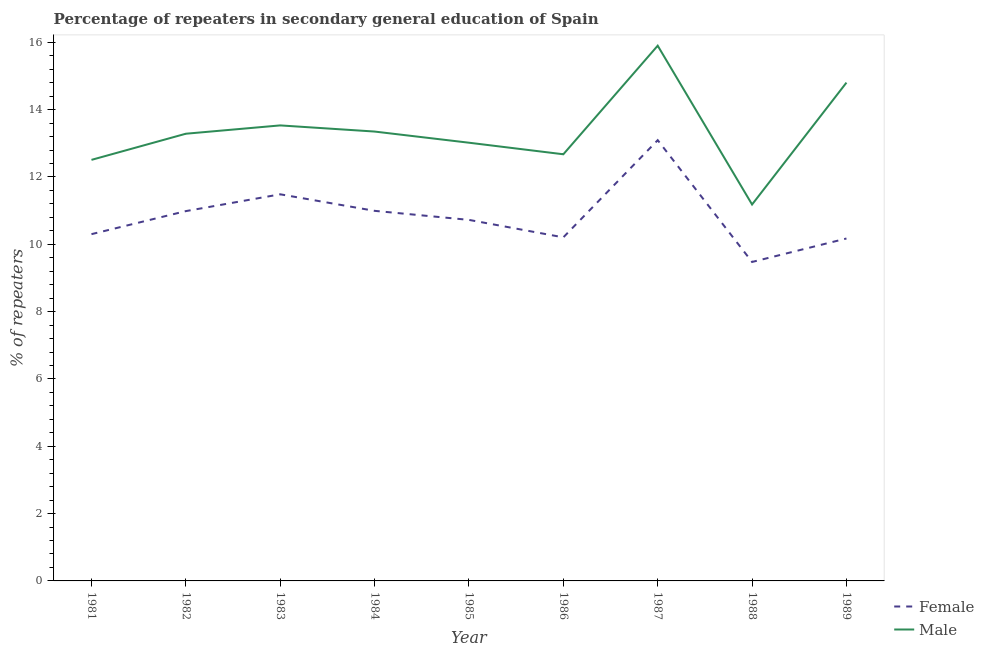Is the number of lines equal to the number of legend labels?
Offer a very short reply. Yes. What is the percentage of male repeaters in 1986?
Offer a terse response. 12.67. Across all years, what is the maximum percentage of female repeaters?
Give a very brief answer. 13.09. Across all years, what is the minimum percentage of female repeaters?
Provide a short and direct response. 9.48. In which year was the percentage of male repeaters maximum?
Your answer should be compact. 1987. In which year was the percentage of female repeaters minimum?
Your answer should be very brief. 1988. What is the total percentage of male repeaters in the graph?
Make the answer very short. 120.25. What is the difference between the percentage of female repeaters in 1982 and that in 1989?
Offer a very short reply. 0.81. What is the difference between the percentage of female repeaters in 1989 and the percentage of male repeaters in 1984?
Your response must be concise. -3.18. What is the average percentage of female repeaters per year?
Offer a terse response. 10.83. In the year 1981, what is the difference between the percentage of female repeaters and percentage of male repeaters?
Provide a succinct answer. -2.21. What is the ratio of the percentage of female repeaters in 1981 to that in 1983?
Keep it short and to the point. 0.9. Is the difference between the percentage of male repeaters in 1985 and 1987 greater than the difference between the percentage of female repeaters in 1985 and 1987?
Offer a very short reply. No. What is the difference between the highest and the second highest percentage of female repeaters?
Ensure brevity in your answer.  1.61. What is the difference between the highest and the lowest percentage of female repeaters?
Offer a terse response. 3.62. In how many years, is the percentage of female repeaters greater than the average percentage of female repeaters taken over all years?
Give a very brief answer. 4. Is the sum of the percentage of male repeaters in 1986 and 1987 greater than the maximum percentage of female repeaters across all years?
Ensure brevity in your answer.  Yes. What is the difference between two consecutive major ticks on the Y-axis?
Give a very brief answer. 2. Are the values on the major ticks of Y-axis written in scientific E-notation?
Offer a terse response. No. Does the graph contain any zero values?
Make the answer very short. No. Where does the legend appear in the graph?
Your answer should be very brief. Bottom right. How many legend labels are there?
Offer a very short reply. 2. What is the title of the graph?
Offer a very short reply. Percentage of repeaters in secondary general education of Spain. What is the label or title of the Y-axis?
Provide a short and direct response. % of repeaters. What is the % of repeaters of Female in 1981?
Your answer should be compact. 10.3. What is the % of repeaters in Male in 1981?
Ensure brevity in your answer.  12.51. What is the % of repeaters of Female in 1982?
Ensure brevity in your answer.  10.99. What is the % of repeaters of Male in 1982?
Your answer should be very brief. 13.28. What is the % of repeaters in Female in 1983?
Provide a succinct answer. 11.49. What is the % of repeaters in Male in 1983?
Your answer should be compact. 13.53. What is the % of repeaters of Female in 1984?
Ensure brevity in your answer.  10.99. What is the % of repeaters in Male in 1984?
Your response must be concise. 13.35. What is the % of repeaters in Female in 1985?
Make the answer very short. 10.73. What is the % of repeaters of Male in 1985?
Ensure brevity in your answer.  13.02. What is the % of repeaters of Female in 1986?
Your answer should be compact. 10.21. What is the % of repeaters in Male in 1986?
Provide a short and direct response. 12.67. What is the % of repeaters of Female in 1987?
Your answer should be compact. 13.09. What is the % of repeaters in Male in 1987?
Keep it short and to the point. 15.9. What is the % of repeaters in Female in 1988?
Your answer should be compact. 9.48. What is the % of repeaters of Male in 1988?
Provide a short and direct response. 11.18. What is the % of repeaters in Female in 1989?
Give a very brief answer. 10.17. What is the % of repeaters of Male in 1989?
Offer a very short reply. 14.8. Across all years, what is the maximum % of repeaters of Female?
Your answer should be compact. 13.09. Across all years, what is the maximum % of repeaters of Male?
Give a very brief answer. 15.9. Across all years, what is the minimum % of repeaters in Female?
Offer a terse response. 9.48. Across all years, what is the minimum % of repeaters of Male?
Your answer should be compact. 11.18. What is the total % of repeaters in Female in the graph?
Make the answer very short. 97.44. What is the total % of repeaters in Male in the graph?
Ensure brevity in your answer.  120.25. What is the difference between the % of repeaters in Female in 1981 and that in 1982?
Your answer should be very brief. -0.68. What is the difference between the % of repeaters in Male in 1981 and that in 1982?
Offer a terse response. -0.78. What is the difference between the % of repeaters in Female in 1981 and that in 1983?
Offer a terse response. -1.18. What is the difference between the % of repeaters of Male in 1981 and that in 1983?
Your answer should be compact. -1.02. What is the difference between the % of repeaters of Female in 1981 and that in 1984?
Keep it short and to the point. -0.69. What is the difference between the % of repeaters of Male in 1981 and that in 1984?
Ensure brevity in your answer.  -0.84. What is the difference between the % of repeaters of Female in 1981 and that in 1985?
Provide a succinct answer. -0.42. What is the difference between the % of repeaters of Male in 1981 and that in 1985?
Give a very brief answer. -0.51. What is the difference between the % of repeaters in Female in 1981 and that in 1986?
Your answer should be very brief. 0.1. What is the difference between the % of repeaters of Male in 1981 and that in 1986?
Make the answer very short. -0.17. What is the difference between the % of repeaters of Female in 1981 and that in 1987?
Offer a terse response. -2.79. What is the difference between the % of repeaters of Male in 1981 and that in 1987?
Offer a terse response. -3.39. What is the difference between the % of repeaters of Female in 1981 and that in 1988?
Provide a short and direct response. 0.83. What is the difference between the % of repeaters of Male in 1981 and that in 1988?
Ensure brevity in your answer.  1.33. What is the difference between the % of repeaters in Female in 1981 and that in 1989?
Provide a succinct answer. 0.13. What is the difference between the % of repeaters in Male in 1981 and that in 1989?
Offer a terse response. -2.3. What is the difference between the % of repeaters of Female in 1982 and that in 1983?
Offer a terse response. -0.5. What is the difference between the % of repeaters of Male in 1982 and that in 1983?
Offer a terse response. -0.25. What is the difference between the % of repeaters in Female in 1982 and that in 1984?
Ensure brevity in your answer.  -0.01. What is the difference between the % of repeaters of Male in 1982 and that in 1984?
Your response must be concise. -0.06. What is the difference between the % of repeaters of Female in 1982 and that in 1985?
Provide a short and direct response. 0.26. What is the difference between the % of repeaters in Male in 1982 and that in 1985?
Your answer should be very brief. 0.27. What is the difference between the % of repeaters in Female in 1982 and that in 1986?
Keep it short and to the point. 0.78. What is the difference between the % of repeaters in Male in 1982 and that in 1986?
Provide a short and direct response. 0.61. What is the difference between the % of repeaters in Female in 1982 and that in 1987?
Your response must be concise. -2.11. What is the difference between the % of repeaters in Male in 1982 and that in 1987?
Ensure brevity in your answer.  -2.62. What is the difference between the % of repeaters of Female in 1982 and that in 1988?
Make the answer very short. 1.51. What is the difference between the % of repeaters of Male in 1982 and that in 1988?
Your response must be concise. 2.1. What is the difference between the % of repeaters of Female in 1982 and that in 1989?
Ensure brevity in your answer.  0.81. What is the difference between the % of repeaters of Male in 1982 and that in 1989?
Give a very brief answer. -1.52. What is the difference between the % of repeaters in Female in 1983 and that in 1984?
Provide a succinct answer. 0.49. What is the difference between the % of repeaters in Male in 1983 and that in 1984?
Your answer should be compact. 0.18. What is the difference between the % of repeaters of Female in 1983 and that in 1985?
Make the answer very short. 0.76. What is the difference between the % of repeaters in Male in 1983 and that in 1985?
Your answer should be compact. 0.51. What is the difference between the % of repeaters in Female in 1983 and that in 1986?
Offer a very short reply. 1.28. What is the difference between the % of repeaters in Male in 1983 and that in 1986?
Keep it short and to the point. 0.86. What is the difference between the % of repeaters in Female in 1983 and that in 1987?
Your answer should be compact. -1.61. What is the difference between the % of repeaters in Male in 1983 and that in 1987?
Make the answer very short. -2.37. What is the difference between the % of repeaters of Female in 1983 and that in 1988?
Your answer should be very brief. 2.01. What is the difference between the % of repeaters in Male in 1983 and that in 1988?
Offer a terse response. 2.35. What is the difference between the % of repeaters in Female in 1983 and that in 1989?
Your answer should be compact. 1.31. What is the difference between the % of repeaters in Male in 1983 and that in 1989?
Give a very brief answer. -1.27. What is the difference between the % of repeaters in Female in 1984 and that in 1985?
Ensure brevity in your answer.  0.27. What is the difference between the % of repeaters of Male in 1984 and that in 1985?
Your answer should be compact. 0.33. What is the difference between the % of repeaters of Female in 1984 and that in 1986?
Ensure brevity in your answer.  0.79. What is the difference between the % of repeaters in Male in 1984 and that in 1986?
Provide a short and direct response. 0.68. What is the difference between the % of repeaters in Female in 1984 and that in 1987?
Ensure brevity in your answer.  -2.1. What is the difference between the % of repeaters of Male in 1984 and that in 1987?
Your response must be concise. -2.55. What is the difference between the % of repeaters in Female in 1984 and that in 1988?
Keep it short and to the point. 1.52. What is the difference between the % of repeaters of Male in 1984 and that in 1988?
Make the answer very short. 2.17. What is the difference between the % of repeaters of Female in 1984 and that in 1989?
Offer a very short reply. 0.82. What is the difference between the % of repeaters of Male in 1984 and that in 1989?
Your response must be concise. -1.45. What is the difference between the % of repeaters in Female in 1985 and that in 1986?
Provide a short and direct response. 0.52. What is the difference between the % of repeaters of Male in 1985 and that in 1986?
Offer a terse response. 0.34. What is the difference between the % of repeaters in Female in 1985 and that in 1987?
Your response must be concise. -2.37. What is the difference between the % of repeaters of Male in 1985 and that in 1987?
Make the answer very short. -2.88. What is the difference between the % of repeaters in Female in 1985 and that in 1988?
Provide a short and direct response. 1.25. What is the difference between the % of repeaters of Male in 1985 and that in 1988?
Give a very brief answer. 1.84. What is the difference between the % of repeaters of Female in 1985 and that in 1989?
Keep it short and to the point. 0.55. What is the difference between the % of repeaters of Male in 1985 and that in 1989?
Keep it short and to the point. -1.79. What is the difference between the % of repeaters of Female in 1986 and that in 1987?
Give a very brief answer. -2.89. What is the difference between the % of repeaters of Male in 1986 and that in 1987?
Ensure brevity in your answer.  -3.23. What is the difference between the % of repeaters in Female in 1986 and that in 1988?
Your response must be concise. 0.73. What is the difference between the % of repeaters of Male in 1986 and that in 1988?
Make the answer very short. 1.49. What is the difference between the % of repeaters of Female in 1986 and that in 1989?
Offer a very short reply. 0.03. What is the difference between the % of repeaters of Male in 1986 and that in 1989?
Your answer should be very brief. -2.13. What is the difference between the % of repeaters in Female in 1987 and that in 1988?
Provide a short and direct response. 3.62. What is the difference between the % of repeaters of Male in 1987 and that in 1988?
Your answer should be very brief. 4.72. What is the difference between the % of repeaters in Female in 1987 and that in 1989?
Keep it short and to the point. 2.92. What is the difference between the % of repeaters of Male in 1987 and that in 1989?
Offer a very short reply. 1.1. What is the difference between the % of repeaters of Female in 1988 and that in 1989?
Offer a terse response. -0.7. What is the difference between the % of repeaters of Male in 1988 and that in 1989?
Provide a succinct answer. -3.62. What is the difference between the % of repeaters of Female in 1981 and the % of repeaters of Male in 1982?
Your answer should be compact. -2.98. What is the difference between the % of repeaters of Female in 1981 and the % of repeaters of Male in 1983?
Give a very brief answer. -3.23. What is the difference between the % of repeaters of Female in 1981 and the % of repeaters of Male in 1984?
Offer a terse response. -3.05. What is the difference between the % of repeaters in Female in 1981 and the % of repeaters in Male in 1985?
Provide a short and direct response. -2.72. What is the difference between the % of repeaters in Female in 1981 and the % of repeaters in Male in 1986?
Give a very brief answer. -2.37. What is the difference between the % of repeaters in Female in 1981 and the % of repeaters in Male in 1987?
Keep it short and to the point. -5.6. What is the difference between the % of repeaters of Female in 1981 and the % of repeaters of Male in 1988?
Provide a short and direct response. -0.88. What is the difference between the % of repeaters of Female in 1981 and the % of repeaters of Male in 1989?
Your answer should be compact. -4.5. What is the difference between the % of repeaters of Female in 1982 and the % of repeaters of Male in 1983?
Give a very brief answer. -2.55. What is the difference between the % of repeaters in Female in 1982 and the % of repeaters in Male in 1984?
Offer a very short reply. -2.36. What is the difference between the % of repeaters of Female in 1982 and the % of repeaters of Male in 1985?
Provide a succinct answer. -2.03. What is the difference between the % of repeaters of Female in 1982 and the % of repeaters of Male in 1986?
Give a very brief answer. -1.69. What is the difference between the % of repeaters of Female in 1982 and the % of repeaters of Male in 1987?
Offer a terse response. -4.91. What is the difference between the % of repeaters of Female in 1982 and the % of repeaters of Male in 1988?
Make the answer very short. -0.2. What is the difference between the % of repeaters in Female in 1982 and the % of repeaters in Male in 1989?
Give a very brief answer. -3.82. What is the difference between the % of repeaters in Female in 1983 and the % of repeaters in Male in 1984?
Keep it short and to the point. -1.86. What is the difference between the % of repeaters of Female in 1983 and the % of repeaters of Male in 1985?
Give a very brief answer. -1.53. What is the difference between the % of repeaters in Female in 1983 and the % of repeaters in Male in 1986?
Ensure brevity in your answer.  -1.19. What is the difference between the % of repeaters in Female in 1983 and the % of repeaters in Male in 1987?
Your answer should be compact. -4.41. What is the difference between the % of repeaters in Female in 1983 and the % of repeaters in Male in 1988?
Give a very brief answer. 0.3. What is the difference between the % of repeaters in Female in 1983 and the % of repeaters in Male in 1989?
Keep it short and to the point. -3.32. What is the difference between the % of repeaters of Female in 1984 and the % of repeaters of Male in 1985?
Your answer should be compact. -2.02. What is the difference between the % of repeaters of Female in 1984 and the % of repeaters of Male in 1986?
Keep it short and to the point. -1.68. What is the difference between the % of repeaters of Female in 1984 and the % of repeaters of Male in 1987?
Your answer should be compact. -4.91. What is the difference between the % of repeaters in Female in 1984 and the % of repeaters in Male in 1988?
Give a very brief answer. -0.19. What is the difference between the % of repeaters in Female in 1984 and the % of repeaters in Male in 1989?
Keep it short and to the point. -3.81. What is the difference between the % of repeaters in Female in 1985 and the % of repeaters in Male in 1986?
Keep it short and to the point. -1.95. What is the difference between the % of repeaters of Female in 1985 and the % of repeaters of Male in 1987?
Provide a succinct answer. -5.17. What is the difference between the % of repeaters of Female in 1985 and the % of repeaters of Male in 1988?
Keep it short and to the point. -0.46. What is the difference between the % of repeaters of Female in 1985 and the % of repeaters of Male in 1989?
Your answer should be very brief. -4.08. What is the difference between the % of repeaters of Female in 1986 and the % of repeaters of Male in 1987?
Your response must be concise. -5.69. What is the difference between the % of repeaters of Female in 1986 and the % of repeaters of Male in 1988?
Offer a terse response. -0.98. What is the difference between the % of repeaters of Female in 1986 and the % of repeaters of Male in 1989?
Provide a succinct answer. -4.6. What is the difference between the % of repeaters of Female in 1987 and the % of repeaters of Male in 1988?
Provide a succinct answer. 1.91. What is the difference between the % of repeaters in Female in 1987 and the % of repeaters in Male in 1989?
Your response must be concise. -1.71. What is the difference between the % of repeaters in Female in 1988 and the % of repeaters in Male in 1989?
Provide a succinct answer. -5.33. What is the average % of repeaters in Female per year?
Offer a very short reply. 10.83. What is the average % of repeaters in Male per year?
Your answer should be very brief. 13.36. In the year 1981, what is the difference between the % of repeaters in Female and % of repeaters in Male?
Offer a very short reply. -2.21. In the year 1982, what is the difference between the % of repeaters in Female and % of repeaters in Male?
Keep it short and to the point. -2.3. In the year 1983, what is the difference between the % of repeaters in Female and % of repeaters in Male?
Your answer should be compact. -2.05. In the year 1984, what is the difference between the % of repeaters of Female and % of repeaters of Male?
Offer a very short reply. -2.36. In the year 1985, what is the difference between the % of repeaters of Female and % of repeaters of Male?
Keep it short and to the point. -2.29. In the year 1986, what is the difference between the % of repeaters in Female and % of repeaters in Male?
Offer a very short reply. -2.47. In the year 1987, what is the difference between the % of repeaters in Female and % of repeaters in Male?
Give a very brief answer. -2.81. In the year 1988, what is the difference between the % of repeaters in Female and % of repeaters in Male?
Provide a succinct answer. -1.71. In the year 1989, what is the difference between the % of repeaters in Female and % of repeaters in Male?
Provide a short and direct response. -4.63. What is the ratio of the % of repeaters in Female in 1981 to that in 1982?
Your answer should be very brief. 0.94. What is the ratio of the % of repeaters of Male in 1981 to that in 1982?
Provide a succinct answer. 0.94. What is the ratio of the % of repeaters of Female in 1981 to that in 1983?
Your response must be concise. 0.9. What is the ratio of the % of repeaters in Male in 1981 to that in 1983?
Offer a very short reply. 0.92. What is the ratio of the % of repeaters in Female in 1981 to that in 1984?
Keep it short and to the point. 0.94. What is the ratio of the % of repeaters in Male in 1981 to that in 1984?
Provide a short and direct response. 0.94. What is the ratio of the % of repeaters of Female in 1981 to that in 1985?
Make the answer very short. 0.96. What is the ratio of the % of repeaters in Male in 1981 to that in 1985?
Keep it short and to the point. 0.96. What is the ratio of the % of repeaters in Female in 1981 to that in 1986?
Your answer should be very brief. 1.01. What is the ratio of the % of repeaters in Male in 1981 to that in 1986?
Provide a succinct answer. 0.99. What is the ratio of the % of repeaters in Female in 1981 to that in 1987?
Offer a terse response. 0.79. What is the ratio of the % of repeaters of Male in 1981 to that in 1987?
Your answer should be very brief. 0.79. What is the ratio of the % of repeaters of Female in 1981 to that in 1988?
Provide a succinct answer. 1.09. What is the ratio of the % of repeaters in Male in 1981 to that in 1988?
Make the answer very short. 1.12. What is the ratio of the % of repeaters of Female in 1981 to that in 1989?
Your answer should be compact. 1.01. What is the ratio of the % of repeaters in Male in 1981 to that in 1989?
Keep it short and to the point. 0.84. What is the ratio of the % of repeaters in Female in 1982 to that in 1983?
Give a very brief answer. 0.96. What is the ratio of the % of repeaters in Male in 1982 to that in 1983?
Your answer should be very brief. 0.98. What is the ratio of the % of repeaters in Male in 1982 to that in 1984?
Offer a terse response. 1. What is the ratio of the % of repeaters of Female in 1982 to that in 1985?
Provide a short and direct response. 1.02. What is the ratio of the % of repeaters in Male in 1982 to that in 1985?
Give a very brief answer. 1.02. What is the ratio of the % of repeaters of Female in 1982 to that in 1986?
Your answer should be compact. 1.08. What is the ratio of the % of repeaters in Male in 1982 to that in 1986?
Offer a terse response. 1.05. What is the ratio of the % of repeaters of Female in 1982 to that in 1987?
Provide a short and direct response. 0.84. What is the ratio of the % of repeaters in Male in 1982 to that in 1987?
Give a very brief answer. 0.84. What is the ratio of the % of repeaters in Female in 1982 to that in 1988?
Offer a terse response. 1.16. What is the ratio of the % of repeaters of Male in 1982 to that in 1988?
Provide a succinct answer. 1.19. What is the ratio of the % of repeaters in Male in 1982 to that in 1989?
Offer a very short reply. 0.9. What is the ratio of the % of repeaters of Female in 1983 to that in 1984?
Keep it short and to the point. 1.04. What is the ratio of the % of repeaters of Male in 1983 to that in 1984?
Make the answer very short. 1.01. What is the ratio of the % of repeaters in Female in 1983 to that in 1985?
Make the answer very short. 1.07. What is the ratio of the % of repeaters in Male in 1983 to that in 1985?
Provide a short and direct response. 1.04. What is the ratio of the % of repeaters of Female in 1983 to that in 1986?
Provide a short and direct response. 1.13. What is the ratio of the % of repeaters of Male in 1983 to that in 1986?
Provide a succinct answer. 1.07. What is the ratio of the % of repeaters of Female in 1983 to that in 1987?
Your answer should be compact. 0.88. What is the ratio of the % of repeaters of Male in 1983 to that in 1987?
Your response must be concise. 0.85. What is the ratio of the % of repeaters of Female in 1983 to that in 1988?
Provide a short and direct response. 1.21. What is the ratio of the % of repeaters in Male in 1983 to that in 1988?
Ensure brevity in your answer.  1.21. What is the ratio of the % of repeaters in Female in 1983 to that in 1989?
Your answer should be compact. 1.13. What is the ratio of the % of repeaters of Male in 1983 to that in 1989?
Your answer should be very brief. 0.91. What is the ratio of the % of repeaters of Female in 1984 to that in 1985?
Provide a succinct answer. 1.03. What is the ratio of the % of repeaters in Male in 1984 to that in 1985?
Keep it short and to the point. 1.03. What is the ratio of the % of repeaters of Female in 1984 to that in 1986?
Make the answer very short. 1.08. What is the ratio of the % of repeaters in Male in 1984 to that in 1986?
Provide a short and direct response. 1.05. What is the ratio of the % of repeaters in Female in 1984 to that in 1987?
Your answer should be compact. 0.84. What is the ratio of the % of repeaters of Male in 1984 to that in 1987?
Give a very brief answer. 0.84. What is the ratio of the % of repeaters in Female in 1984 to that in 1988?
Make the answer very short. 1.16. What is the ratio of the % of repeaters of Male in 1984 to that in 1988?
Offer a terse response. 1.19. What is the ratio of the % of repeaters of Female in 1984 to that in 1989?
Keep it short and to the point. 1.08. What is the ratio of the % of repeaters of Male in 1984 to that in 1989?
Keep it short and to the point. 0.9. What is the ratio of the % of repeaters in Female in 1985 to that in 1986?
Your response must be concise. 1.05. What is the ratio of the % of repeaters in Male in 1985 to that in 1986?
Provide a succinct answer. 1.03. What is the ratio of the % of repeaters in Female in 1985 to that in 1987?
Offer a very short reply. 0.82. What is the ratio of the % of repeaters of Male in 1985 to that in 1987?
Your answer should be very brief. 0.82. What is the ratio of the % of repeaters in Female in 1985 to that in 1988?
Your answer should be compact. 1.13. What is the ratio of the % of repeaters in Male in 1985 to that in 1988?
Give a very brief answer. 1.16. What is the ratio of the % of repeaters in Female in 1985 to that in 1989?
Your response must be concise. 1.05. What is the ratio of the % of repeaters of Male in 1985 to that in 1989?
Ensure brevity in your answer.  0.88. What is the ratio of the % of repeaters of Female in 1986 to that in 1987?
Ensure brevity in your answer.  0.78. What is the ratio of the % of repeaters of Male in 1986 to that in 1987?
Offer a terse response. 0.8. What is the ratio of the % of repeaters of Female in 1986 to that in 1988?
Your answer should be very brief. 1.08. What is the ratio of the % of repeaters of Male in 1986 to that in 1988?
Make the answer very short. 1.13. What is the ratio of the % of repeaters of Male in 1986 to that in 1989?
Provide a short and direct response. 0.86. What is the ratio of the % of repeaters of Female in 1987 to that in 1988?
Ensure brevity in your answer.  1.38. What is the ratio of the % of repeaters of Male in 1987 to that in 1988?
Provide a succinct answer. 1.42. What is the ratio of the % of repeaters of Female in 1987 to that in 1989?
Your response must be concise. 1.29. What is the ratio of the % of repeaters of Male in 1987 to that in 1989?
Provide a short and direct response. 1.07. What is the ratio of the % of repeaters of Female in 1988 to that in 1989?
Ensure brevity in your answer.  0.93. What is the ratio of the % of repeaters of Male in 1988 to that in 1989?
Make the answer very short. 0.76. What is the difference between the highest and the second highest % of repeaters of Female?
Ensure brevity in your answer.  1.61. What is the difference between the highest and the second highest % of repeaters in Male?
Your answer should be very brief. 1.1. What is the difference between the highest and the lowest % of repeaters of Female?
Offer a terse response. 3.62. What is the difference between the highest and the lowest % of repeaters of Male?
Your answer should be very brief. 4.72. 